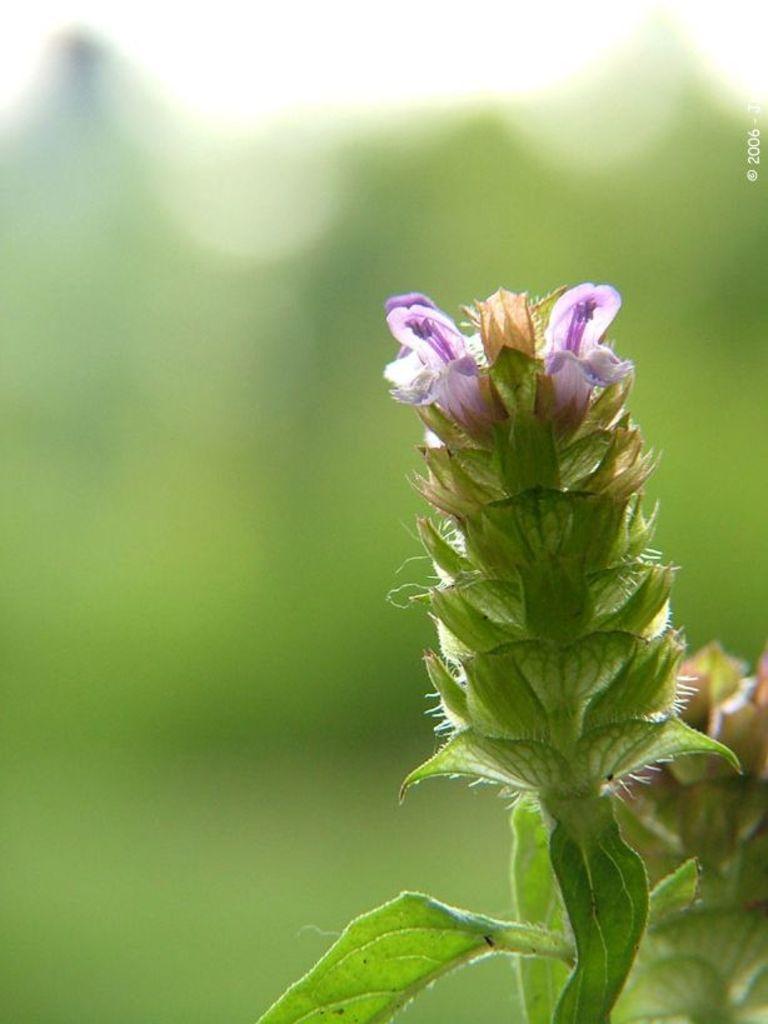How would you summarize this image in a sentence or two? In this image, I can see a plant with flowers and leaves. The background looks green in color. At the right side of the image, I can see the watermark. 